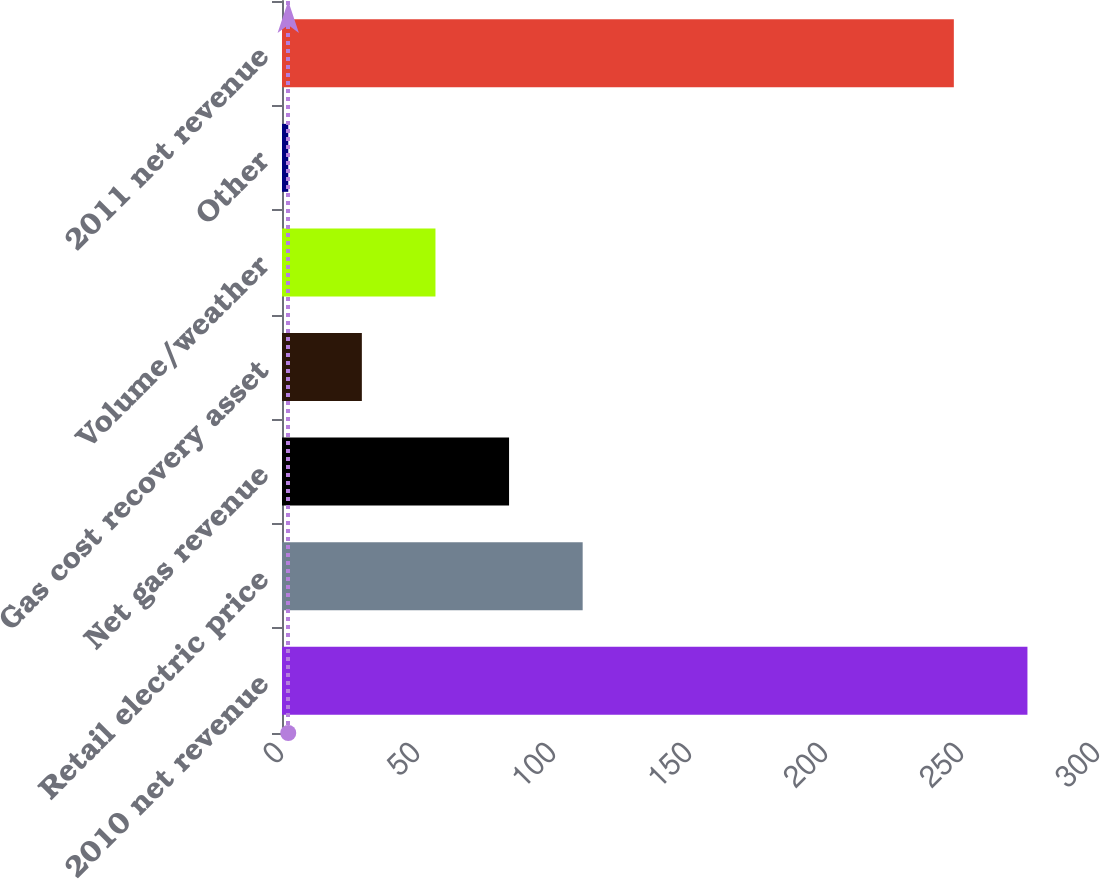Convert chart to OTSL. <chart><loc_0><loc_0><loc_500><loc_500><bar_chart><fcel>2010 net revenue<fcel>Retail electric price<fcel>Net gas revenue<fcel>Gas cost recovery asset<fcel>Volume/weather<fcel>Other<fcel>2011 net revenue<nl><fcel>274.06<fcel>110.54<fcel>83.48<fcel>29.36<fcel>56.42<fcel>2.3<fcel>247<nl></chart> 